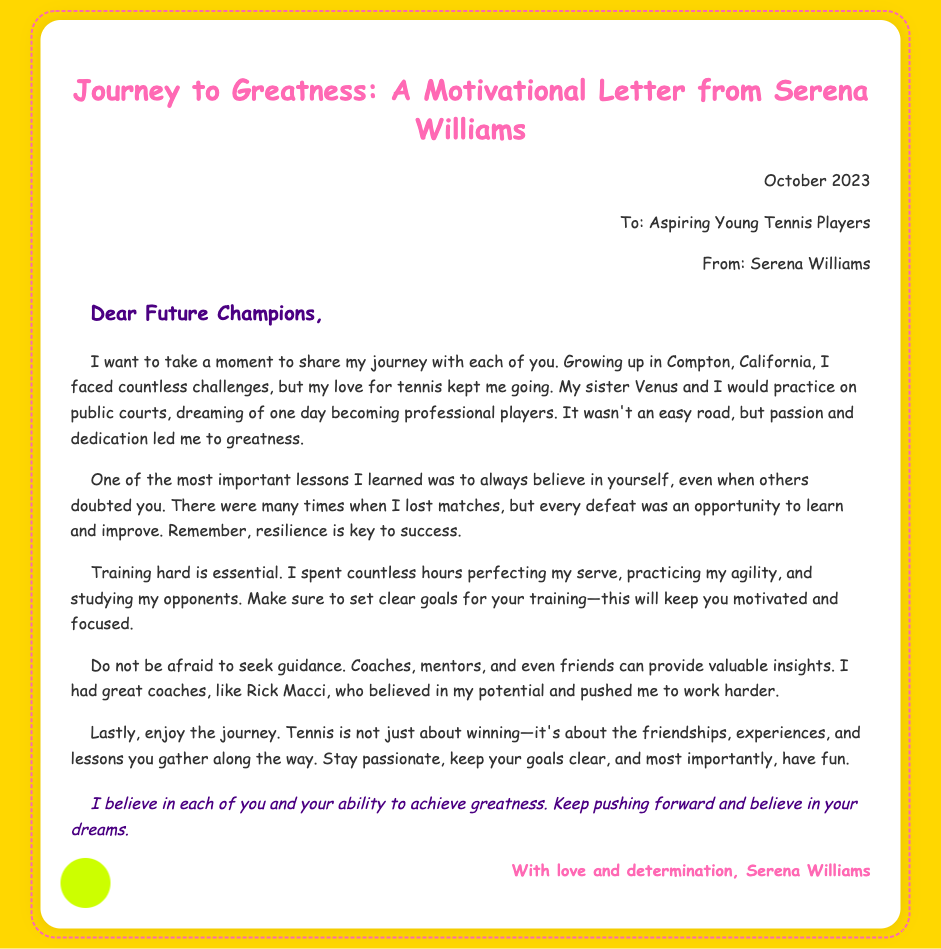What is the date of the letter? The date mentioned in the document is stated at the top of the letter.
Answer: October 2023 Who is the letter addressed to? The recipient of the letter is indicated in the header section.
Answer: Aspiring Young Tennis Players What is the name of the sender? The sender's name can be found in the header of the document.
Answer: Serena Williams What city did Serena Williams grow up in? The city mentioned in the text is where Serena Williams spent her childhood.
Answer: Compton What is one important lesson Serena emphasizes? The lesson about believing in oneself is highlighted in the letter.
Answer: Believe in yourself Who was one of Serena's coaches? The coach that is specifically mentioned in her letter is listed as someone who influenced her career.
Answer: Rick Macci What should young athletes focus on besides winning? The document suggests that there are other important aspects to tennis beyond competition.
Answer: Enjoy the journey What is Serena's advice regarding losses? The letter conveys a specific viewpoint on how to approach losses in tennis matches.
Answer: Opportunity to learn 